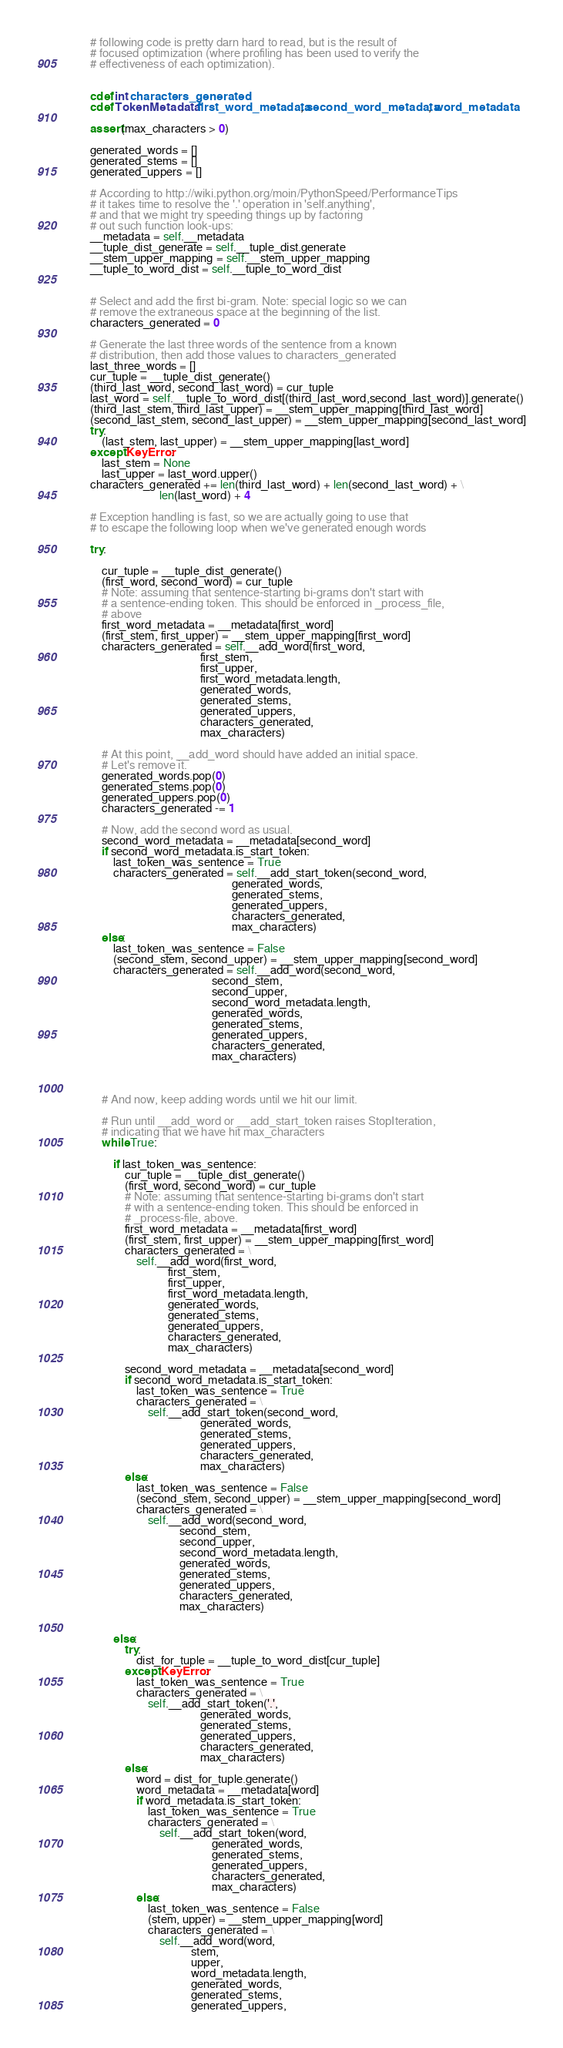<code> <loc_0><loc_0><loc_500><loc_500><_Cython_>        # following code is pretty darn hard to read, but is the result of
        # focused optimization (where profiling has been used to verify the
        # effectiveness of each optimization).
        
        
        cdef int characters_generated 
        cdef TokenMetadata first_word_metadata, second_word_metadata, word_metadata
        
        assert(max_characters > 0)

        generated_words = []
        generated_stems = []
        generated_uppers = []

        # According to http://wiki.python.org/moin/PythonSpeed/PerformanceTips
        # it takes time to resolve the '.' operation in 'self.anything',
        # and that we might try speeding things up by factoring
        # out such function look-ups:
        __metadata = self.__metadata
        __tuple_dist_generate = self.__tuple_dist.generate
        __stem_upper_mapping = self.__stem_upper_mapping
        __tuple_to_word_dist = self.__tuple_to_word_dist


        # Select and add the first bi-gram. Note: special logic so we can
        # remove the extraneous space at the beginning of the list.
        characters_generated = 0

        # Generate the last three words of the sentence from a known 
        # distribution, then add those values to characters_generated
        last_three_words = []
        cur_tuple = __tuple_dist_generate()
        (third_last_word, second_last_word) = cur_tuple
        last_word = self.__tuple_to_word_dist[(third_last_word,second_last_word)].generate()
        (third_last_stem, third_last_upper) = __stem_upper_mapping[third_last_word]
        (second_last_stem, second_last_upper) = __stem_upper_mapping[second_last_word]
        try:
            (last_stem, last_upper) = __stem_upper_mapping[last_word]
        except KeyError:
            last_stem = None
            last_upper = last_word.upper()
        characters_generated += len(third_last_word) + len(second_last_word) + \
                                len(last_word) + 4
                        
        # Exception handling is fast, so we are actually going to use that
        # to escape the following loop when we've generated enough words

        try:
            
            cur_tuple = __tuple_dist_generate()
            (first_word, second_word) = cur_tuple
            # Note: assuming that sentence-starting bi-grams don't start with 
            # a sentence-ending token. This should be enforced in _process_file,
            # above
            first_word_metadata = __metadata[first_word]
            (first_stem, first_upper) = __stem_upper_mapping[first_word]
            characters_generated = self.__add_word(first_word,
                                              first_stem,
                                              first_upper,
                                              first_word_metadata.length, 
                                              generated_words,
                                              generated_stems,
                                              generated_uppers,
                                              characters_generated,
                                              max_characters)
                
            # At this point, __add_word should have added an initial space.
            # Let's remove it.
            generated_words.pop(0)
            generated_stems.pop(0)
            generated_uppers.pop(0)
            characters_generated -= 1
            
            # Now, add the second word as usual.
            second_word_metadata = __metadata[second_word]
            if second_word_metadata.is_start_token:
                last_token_was_sentence = True
                characters_generated = self.__add_start_token(second_word, 
                                                         generated_words,
                                                         generated_stems,
                                                         generated_uppers,
                                                         characters_generated,
                                                         max_characters)
            else:
                last_token_was_sentence = False
                (second_stem, second_upper) = __stem_upper_mapping[second_word]
                characters_generated = self.__add_word(second_word,
                                                  second_stem,
                                                  second_upper,
                                                  second_word_metadata.length, 
                                                  generated_words,
                                                  generated_stems,
                                                  generated_uppers,
                                                  characters_generated,
                                                  max_characters)                    
            
    
    
            # And now, keep adding words until we hit our limit.
        
            # Run until __add_word or __add_start_token raises StopIteration,
            # indicating that we have hit max_characters
            while True:

                if last_token_was_sentence:
                    cur_tuple = __tuple_dist_generate()
                    (first_word, second_word) = cur_tuple
                    # Note: assuming that sentence-starting bi-grams don't start
                    # with a sentence-ending token. This should be enforced in 
                    # _process-file, above.
                    first_word_metadata = __metadata[first_word]
                    (first_stem, first_upper) = __stem_upper_mapping[first_word]
                    characters_generated = \
                        self.__add_word(first_word, 
                                   first_stem,
                                   first_upper,
                                   first_word_metadata.length,     
                                   generated_words,
                                   generated_stems,
                                   generated_uppers,
                                   characters_generated,
                                   max_characters)
                        
                    second_word_metadata = __metadata[second_word]
                    if second_word_metadata.is_start_token:
                        last_token_was_sentence = True
                        characters_generated = \
                            self.__add_start_token(second_word, 
                                              generated_words,
                                              generated_stems,
                                              generated_uppers,
                                              characters_generated,
                                              max_characters)
                    else:
                        last_token_was_sentence = False
                        (second_stem, second_upper) = __stem_upper_mapping[second_word]
                        characters_generated = \
                            self.__add_word(second_word,
                                       second_stem,
                                       second_upper,
                                       second_word_metadata.length, 
                                       generated_words,
                                       generated_stems,
                                       generated_uppers,
                                       characters_generated,
                                       max_characters)                    
                    
                    
                else:
                    try:
                        dist_for_tuple = __tuple_to_word_dist[cur_tuple]
                    except KeyError:
                        last_token_was_sentence = True
                        characters_generated = \
                            self.__add_start_token('.', 
                                              generated_words,
                                              generated_stems,
                                              generated_uppers,
                                              characters_generated,
                                              max_characters)
                    else:
                        word = dist_for_tuple.generate()
                        word_metadata = __metadata[word]
                        if word_metadata.is_start_token:
                            last_token_was_sentence = True
                            characters_generated = \
                                self.__add_start_token(word, 
                                                  generated_words,
                                                  generated_stems,
                                                  generated_uppers,
                                                  characters_generated,
                                                  max_characters)
                        else:
                            last_token_was_sentence = False
                            (stem, upper) = __stem_upper_mapping[word]
                            characters_generated = \
                                self.__add_word(word,
                                           stem,
                                           upper,
                                           word_metadata.length, 
                                           generated_words,
                                           generated_stems,
                                           generated_uppers,</code> 